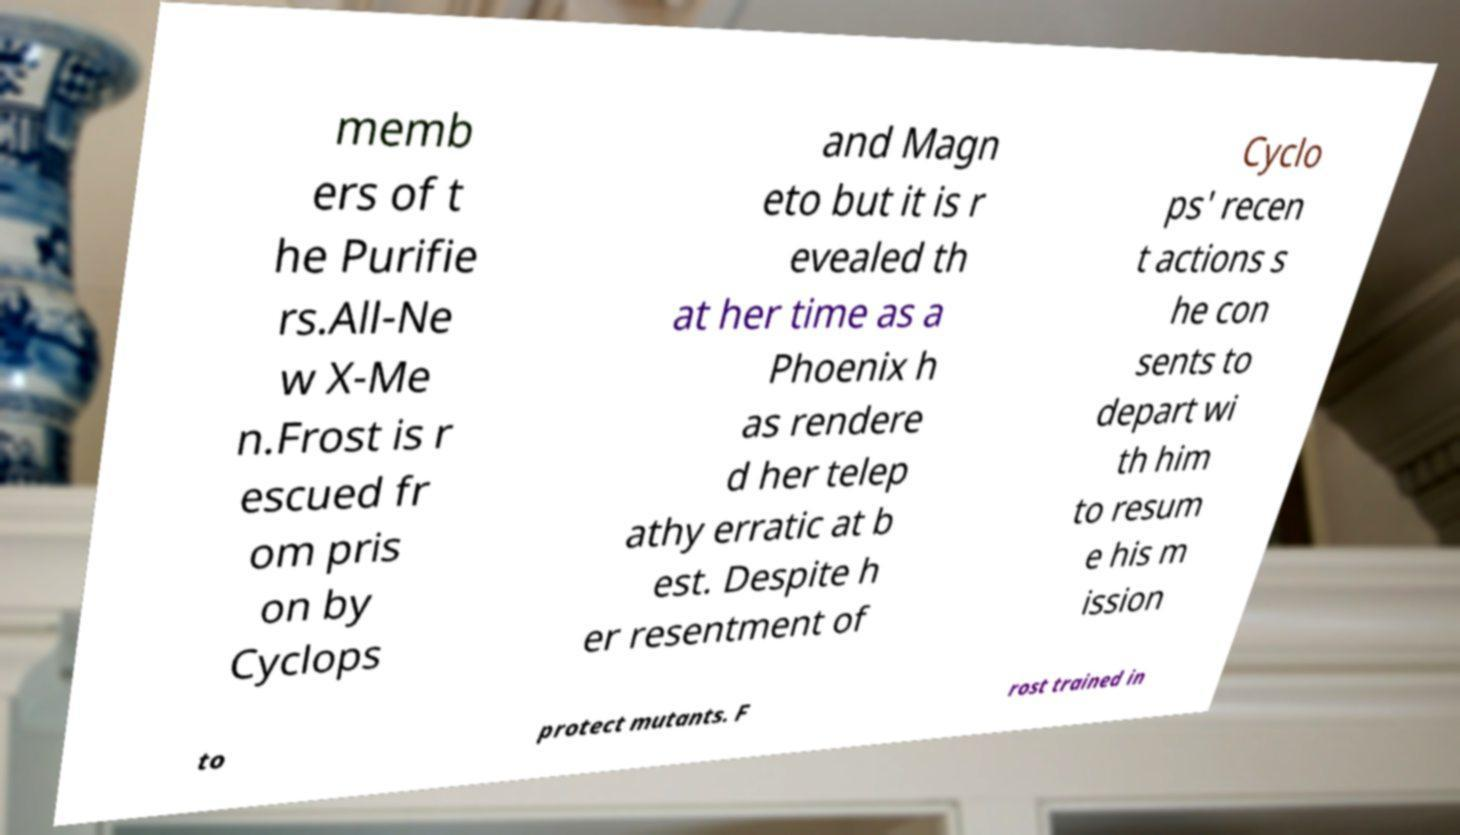Can you read and provide the text displayed in the image?This photo seems to have some interesting text. Can you extract and type it out for me? memb ers of t he Purifie rs.All-Ne w X-Me n.Frost is r escued fr om pris on by Cyclops and Magn eto but it is r evealed th at her time as a Phoenix h as rendere d her telep athy erratic at b est. Despite h er resentment of Cyclo ps' recen t actions s he con sents to depart wi th him to resum e his m ission to protect mutants. F rost trained in 